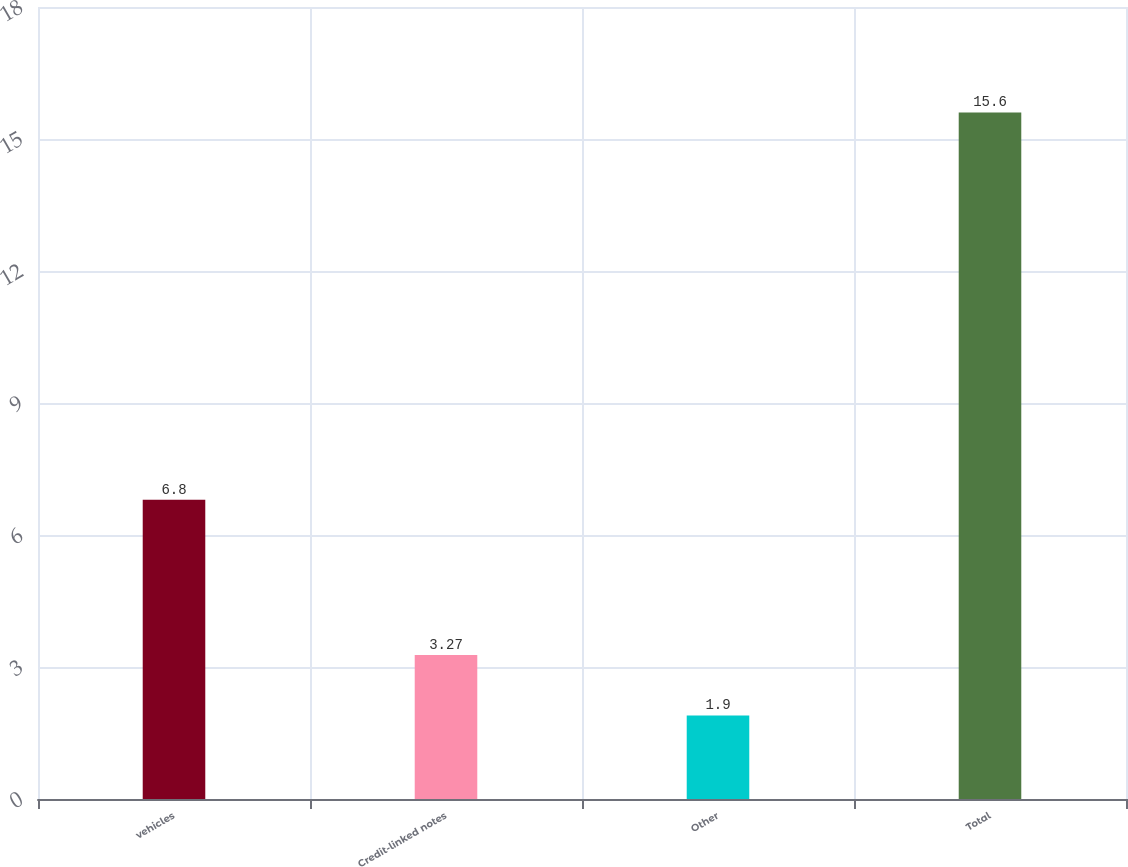Convert chart. <chart><loc_0><loc_0><loc_500><loc_500><bar_chart><fcel>vehicles<fcel>Credit-linked notes<fcel>Other<fcel>Total<nl><fcel>6.8<fcel>3.27<fcel>1.9<fcel>15.6<nl></chart> 